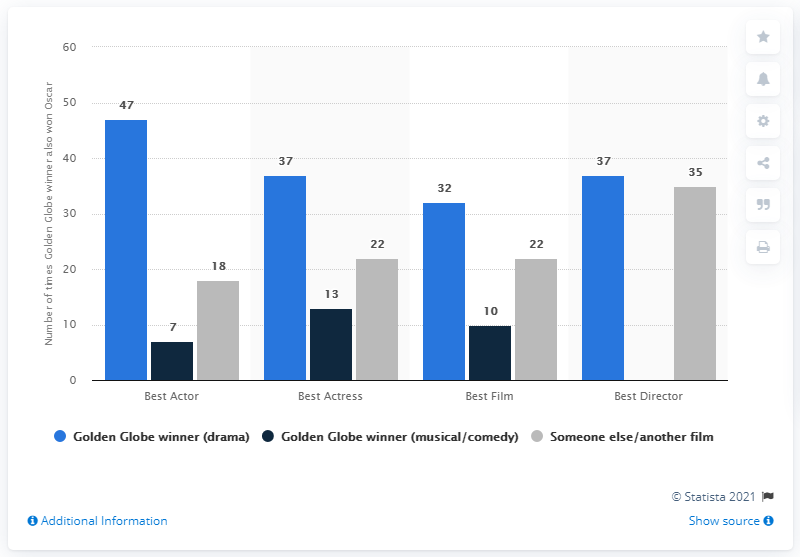Highlight a few significant elements in this photo. The Academy Award for Best Director has been won by a Golden Globe winner in the same year 37 times. 